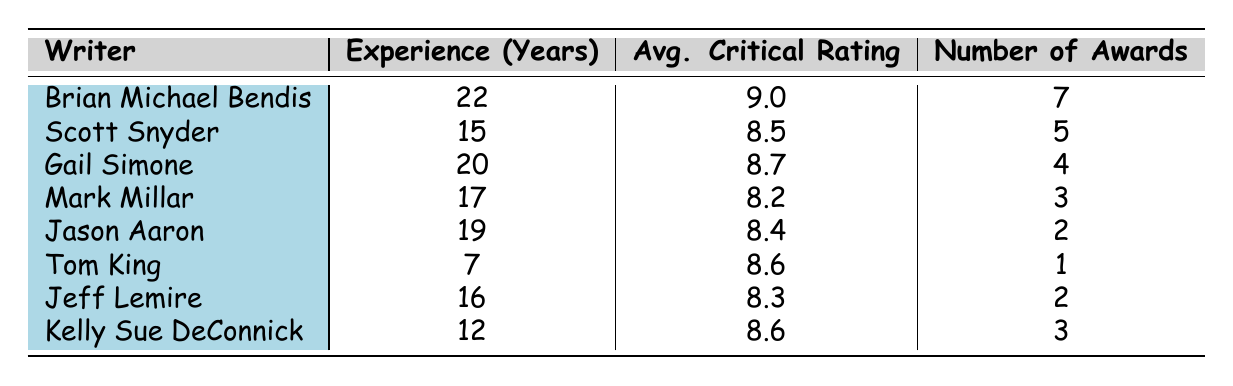What is the average critical rating of Brian Michael Bendis? The table indicates that Brian Michael Bendis has an average critical rating of 9.0.
Answer: 9.0 How many awards did Gail Simone win? According to the table, Gail Simone won 4 awards.
Answer: 4 Is the average critical rating of writers with more than 15 years of experience generally higher than those with less? From the data, Scott Snyder (15 years, 8.5), Gail Simone (20 years, 8.7), Mark Millar (17 years, 8.2), Jason Aaron (19 years, 8.4), and Jeff Lemire (16 years, 8.3) average to around 8.52, while Tom King (7 years, 8.6) is lower. Hence, yes.
Answer: Yes What is the difference in the number of awards between Brian Michael Bendis and Mark Millar? Brian Michael Bendis has 7 awards, and Mark Millar has 3. The difference is 7 - 3 = 4.
Answer: 4 Which writer has the lowest average critical rating? The table shows that Mark Millar has the lowest average critical rating at 8.2.
Answer: Mark Millar If we look at all writers in the table, what is the total number of years of experience combined? Adding the experience years: 22 (Bendis) + 15 (Snyder) + 20 (Simone) + 17 (Millar) + 19 (Aaron) + 7 (King) + 16 (Lemire) + 12 (DeConnick) = 128 years total.
Answer: 128 Are there any writers with an average critical rating above 9.0? By checking the table, it’s clear that Brian Michael Bendis is the only writer with a rating above 9.0, at 9.0, confirming that he stands out.
Answer: No What is the average number of awards won by writers with more than 10 years of experience? The writers with more than 10 years of experience are Bendis (7), Snyder (5), Simone (4), Millar (3), Aaron (2), Lemire (2), and DeConnick (3). There are 7 writers, and their total awards are 7 + 5 + 4 + 3 + 2 + 2 + 3 = 26. Hence, the average is 26 / 7 ≈ 3.71.
Answer: 3.71 